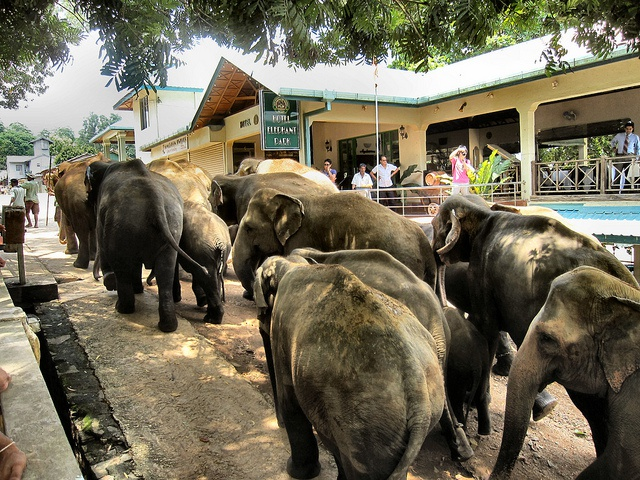Describe the objects in this image and their specific colors. I can see elephant in black, gray, and tan tones, elephant in black and gray tones, elephant in black, gray, and tan tones, elephant in black, gray, and darkgray tones, and elephant in black, gray, and tan tones in this image. 